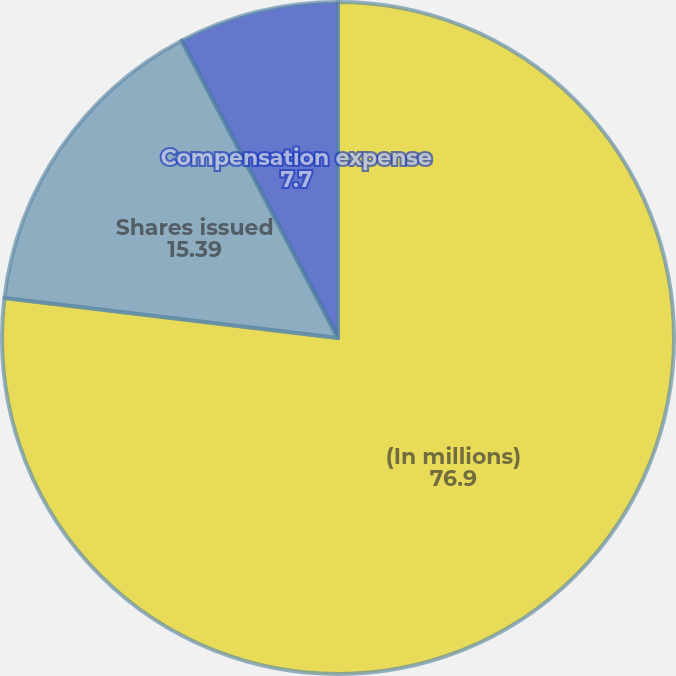Convert chart. <chart><loc_0><loc_0><loc_500><loc_500><pie_chart><fcel>(In millions)<fcel>Shares issued<fcel>Total value granted<fcel>Compensation expense<nl><fcel>76.9%<fcel>15.39%<fcel>0.01%<fcel>7.7%<nl></chart> 